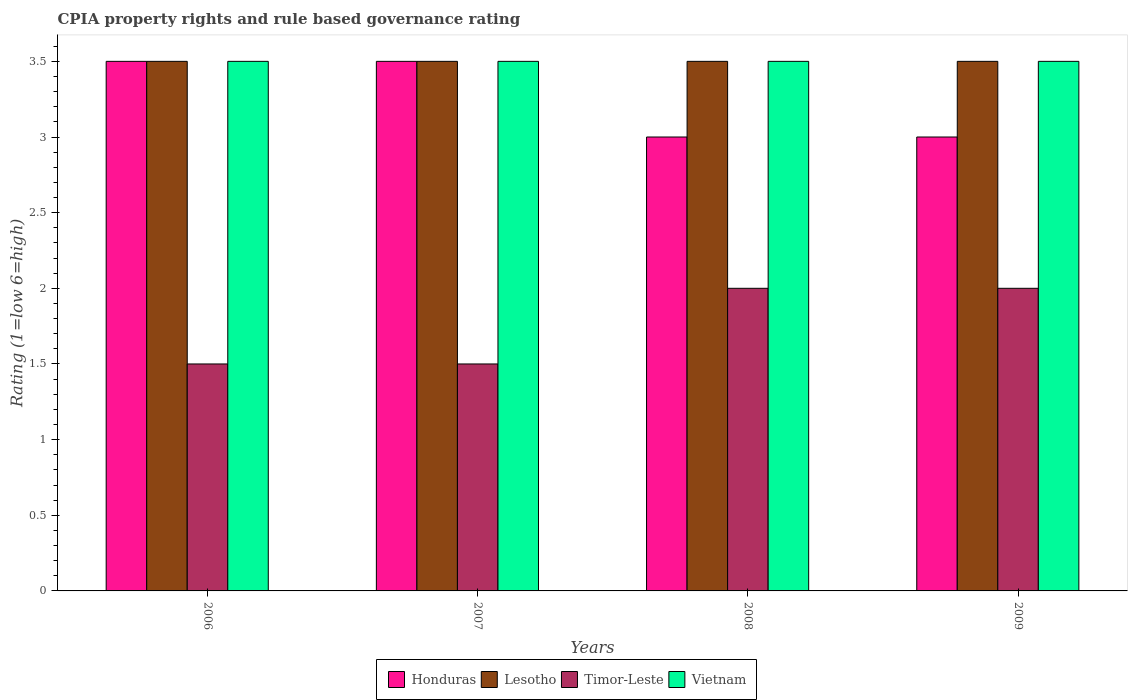How many groups of bars are there?
Give a very brief answer. 4. Are the number of bars per tick equal to the number of legend labels?
Offer a very short reply. Yes. Are the number of bars on each tick of the X-axis equal?
Your answer should be very brief. Yes. How many bars are there on the 4th tick from the right?
Your response must be concise. 4. In how many cases, is the number of bars for a given year not equal to the number of legend labels?
Ensure brevity in your answer.  0. In which year was the CPIA rating in Lesotho maximum?
Your answer should be very brief. 2006. What is the total CPIA rating in Vietnam in the graph?
Keep it short and to the point. 14. What is the difference between the CPIA rating in Lesotho in 2008 and that in 2009?
Offer a very short reply. 0. What is the difference between the CPIA rating in Honduras in 2009 and the CPIA rating in Timor-Leste in 2006?
Give a very brief answer. 1.5. Is the difference between the CPIA rating in Vietnam in 2006 and 2008 greater than the difference between the CPIA rating in Honduras in 2006 and 2008?
Give a very brief answer. No. What is the difference between the highest and the second highest CPIA rating in Vietnam?
Provide a succinct answer. 0. What is the difference between the highest and the lowest CPIA rating in Timor-Leste?
Provide a succinct answer. 0.5. In how many years, is the CPIA rating in Vietnam greater than the average CPIA rating in Vietnam taken over all years?
Make the answer very short. 0. Is it the case that in every year, the sum of the CPIA rating in Timor-Leste and CPIA rating in Vietnam is greater than the sum of CPIA rating in Lesotho and CPIA rating in Honduras?
Make the answer very short. No. What does the 4th bar from the left in 2009 represents?
Your answer should be compact. Vietnam. What does the 3rd bar from the right in 2008 represents?
Give a very brief answer. Lesotho. How many bars are there?
Offer a very short reply. 16. Are all the bars in the graph horizontal?
Offer a very short reply. No. Are the values on the major ticks of Y-axis written in scientific E-notation?
Ensure brevity in your answer.  No. Does the graph contain grids?
Offer a terse response. No. Where does the legend appear in the graph?
Your answer should be compact. Bottom center. What is the title of the graph?
Provide a short and direct response. CPIA property rights and rule based governance rating. Does "Lebanon" appear as one of the legend labels in the graph?
Keep it short and to the point. No. What is the Rating (1=low 6=high) of Honduras in 2006?
Your answer should be very brief. 3.5. What is the Rating (1=low 6=high) of Lesotho in 2006?
Make the answer very short. 3.5. What is the Rating (1=low 6=high) of Vietnam in 2006?
Provide a short and direct response. 3.5. What is the Rating (1=low 6=high) of Honduras in 2008?
Provide a succinct answer. 3. What is the Rating (1=low 6=high) in Lesotho in 2008?
Offer a very short reply. 3.5. What is the Rating (1=low 6=high) of Vietnam in 2008?
Provide a succinct answer. 3.5. What is the Rating (1=low 6=high) in Lesotho in 2009?
Keep it short and to the point. 3.5. What is the Rating (1=low 6=high) of Timor-Leste in 2009?
Provide a short and direct response. 2. What is the Rating (1=low 6=high) of Vietnam in 2009?
Your answer should be compact. 3.5. Across all years, what is the maximum Rating (1=low 6=high) of Honduras?
Your answer should be compact. 3.5. Across all years, what is the maximum Rating (1=low 6=high) in Timor-Leste?
Provide a succinct answer. 2. Across all years, what is the minimum Rating (1=low 6=high) of Vietnam?
Ensure brevity in your answer.  3.5. What is the total Rating (1=low 6=high) in Honduras in the graph?
Give a very brief answer. 13. What is the total Rating (1=low 6=high) of Lesotho in the graph?
Provide a short and direct response. 14. What is the difference between the Rating (1=low 6=high) of Honduras in 2006 and that in 2007?
Your answer should be very brief. 0. What is the difference between the Rating (1=low 6=high) of Lesotho in 2006 and that in 2007?
Offer a terse response. 0. What is the difference between the Rating (1=low 6=high) of Timor-Leste in 2006 and that in 2007?
Your response must be concise. 0. What is the difference between the Rating (1=low 6=high) in Vietnam in 2006 and that in 2007?
Keep it short and to the point. 0. What is the difference between the Rating (1=low 6=high) in Vietnam in 2006 and that in 2008?
Keep it short and to the point. 0. What is the difference between the Rating (1=low 6=high) in Lesotho in 2007 and that in 2008?
Your answer should be compact. 0. What is the difference between the Rating (1=low 6=high) of Vietnam in 2007 and that in 2008?
Offer a very short reply. 0. What is the difference between the Rating (1=low 6=high) in Honduras in 2007 and that in 2009?
Your response must be concise. 0.5. What is the difference between the Rating (1=low 6=high) of Honduras in 2008 and that in 2009?
Offer a very short reply. 0. What is the difference between the Rating (1=low 6=high) of Timor-Leste in 2008 and that in 2009?
Your answer should be compact. 0. What is the difference between the Rating (1=low 6=high) in Honduras in 2006 and the Rating (1=low 6=high) in Timor-Leste in 2007?
Keep it short and to the point. 2. What is the difference between the Rating (1=low 6=high) in Lesotho in 2006 and the Rating (1=low 6=high) in Vietnam in 2007?
Provide a succinct answer. 0. What is the difference between the Rating (1=low 6=high) in Timor-Leste in 2006 and the Rating (1=low 6=high) in Vietnam in 2007?
Ensure brevity in your answer.  -2. What is the difference between the Rating (1=low 6=high) in Honduras in 2006 and the Rating (1=low 6=high) in Timor-Leste in 2008?
Your response must be concise. 1.5. What is the difference between the Rating (1=low 6=high) of Honduras in 2006 and the Rating (1=low 6=high) of Vietnam in 2008?
Make the answer very short. 0. What is the difference between the Rating (1=low 6=high) of Honduras in 2006 and the Rating (1=low 6=high) of Timor-Leste in 2009?
Your answer should be very brief. 1.5. What is the difference between the Rating (1=low 6=high) of Honduras in 2006 and the Rating (1=low 6=high) of Vietnam in 2009?
Keep it short and to the point. 0. What is the difference between the Rating (1=low 6=high) in Lesotho in 2006 and the Rating (1=low 6=high) in Timor-Leste in 2009?
Your answer should be compact. 1.5. What is the difference between the Rating (1=low 6=high) in Timor-Leste in 2006 and the Rating (1=low 6=high) in Vietnam in 2009?
Your answer should be compact. -2. What is the difference between the Rating (1=low 6=high) in Honduras in 2007 and the Rating (1=low 6=high) in Lesotho in 2008?
Offer a very short reply. 0. What is the difference between the Rating (1=low 6=high) in Honduras in 2007 and the Rating (1=low 6=high) in Timor-Leste in 2008?
Your answer should be compact. 1.5. What is the difference between the Rating (1=low 6=high) in Honduras in 2007 and the Rating (1=low 6=high) in Vietnam in 2008?
Provide a short and direct response. 0. What is the difference between the Rating (1=low 6=high) of Honduras in 2007 and the Rating (1=low 6=high) of Lesotho in 2009?
Offer a terse response. 0. What is the difference between the Rating (1=low 6=high) in Honduras in 2007 and the Rating (1=low 6=high) in Vietnam in 2009?
Your answer should be compact. 0. What is the difference between the Rating (1=low 6=high) in Lesotho in 2007 and the Rating (1=low 6=high) in Timor-Leste in 2009?
Keep it short and to the point. 1.5. What is the difference between the Rating (1=low 6=high) of Timor-Leste in 2007 and the Rating (1=low 6=high) of Vietnam in 2009?
Your answer should be very brief. -2. What is the difference between the Rating (1=low 6=high) of Honduras in 2008 and the Rating (1=low 6=high) of Timor-Leste in 2009?
Your answer should be compact. 1. What is the difference between the Rating (1=low 6=high) in Lesotho in 2008 and the Rating (1=low 6=high) in Timor-Leste in 2009?
Make the answer very short. 1.5. What is the difference between the Rating (1=low 6=high) in Lesotho in 2008 and the Rating (1=low 6=high) in Vietnam in 2009?
Provide a succinct answer. 0. What is the difference between the Rating (1=low 6=high) of Timor-Leste in 2008 and the Rating (1=low 6=high) of Vietnam in 2009?
Offer a terse response. -1.5. What is the average Rating (1=low 6=high) of Honduras per year?
Give a very brief answer. 3.25. What is the average Rating (1=low 6=high) of Lesotho per year?
Make the answer very short. 3.5. In the year 2006, what is the difference between the Rating (1=low 6=high) of Honduras and Rating (1=low 6=high) of Vietnam?
Your answer should be very brief. 0. In the year 2006, what is the difference between the Rating (1=low 6=high) in Lesotho and Rating (1=low 6=high) in Vietnam?
Give a very brief answer. 0. In the year 2006, what is the difference between the Rating (1=low 6=high) of Timor-Leste and Rating (1=low 6=high) of Vietnam?
Give a very brief answer. -2. In the year 2007, what is the difference between the Rating (1=low 6=high) in Honduras and Rating (1=low 6=high) in Vietnam?
Your answer should be compact. 0. In the year 2007, what is the difference between the Rating (1=low 6=high) in Lesotho and Rating (1=low 6=high) in Vietnam?
Provide a succinct answer. 0. In the year 2007, what is the difference between the Rating (1=low 6=high) of Timor-Leste and Rating (1=low 6=high) of Vietnam?
Offer a terse response. -2. In the year 2008, what is the difference between the Rating (1=low 6=high) in Honduras and Rating (1=low 6=high) in Lesotho?
Offer a terse response. -0.5. In the year 2008, what is the difference between the Rating (1=low 6=high) in Honduras and Rating (1=low 6=high) in Vietnam?
Provide a short and direct response. -0.5. In the year 2008, what is the difference between the Rating (1=low 6=high) in Timor-Leste and Rating (1=low 6=high) in Vietnam?
Make the answer very short. -1.5. In the year 2009, what is the difference between the Rating (1=low 6=high) in Honduras and Rating (1=low 6=high) in Lesotho?
Your answer should be compact. -0.5. In the year 2009, what is the difference between the Rating (1=low 6=high) in Honduras and Rating (1=low 6=high) in Vietnam?
Keep it short and to the point. -0.5. In the year 2009, what is the difference between the Rating (1=low 6=high) of Lesotho and Rating (1=low 6=high) of Timor-Leste?
Keep it short and to the point. 1.5. In the year 2009, what is the difference between the Rating (1=low 6=high) of Lesotho and Rating (1=low 6=high) of Vietnam?
Your response must be concise. 0. What is the ratio of the Rating (1=low 6=high) of Honduras in 2006 to that in 2007?
Your answer should be very brief. 1. What is the ratio of the Rating (1=low 6=high) in Honduras in 2006 to that in 2008?
Give a very brief answer. 1.17. What is the ratio of the Rating (1=low 6=high) in Lesotho in 2006 to that in 2008?
Offer a terse response. 1. What is the ratio of the Rating (1=low 6=high) of Timor-Leste in 2006 to that in 2009?
Keep it short and to the point. 0.75. What is the ratio of the Rating (1=low 6=high) of Lesotho in 2007 to that in 2008?
Offer a very short reply. 1. What is the ratio of the Rating (1=low 6=high) of Timor-Leste in 2007 to that in 2008?
Offer a very short reply. 0.75. What is the ratio of the Rating (1=low 6=high) in Timor-Leste in 2007 to that in 2009?
Make the answer very short. 0.75. What is the ratio of the Rating (1=low 6=high) of Vietnam in 2007 to that in 2009?
Offer a terse response. 1. What is the ratio of the Rating (1=low 6=high) of Vietnam in 2008 to that in 2009?
Provide a short and direct response. 1. What is the difference between the highest and the second highest Rating (1=low 6=high) of Honduras?
Provide a short and direct response. 0. What is the difference between the highest and the second highest Rating (1=low 6=high) of Lesotho?
Keep it short and to the point. 0. What is the difference between the highest and the lowest Rating (1=low 6=high) of Lesotho?
Offer a terse response. 0. What is the difference between the highest and the lowest Rating (1=low 6=high) of Timor-Leste?
Offer a very short reply. 0.5. What is the difference between the highest and the lowest Rating (1=low 6=high) in Vietnam?
Your answer should be compact. 0. 